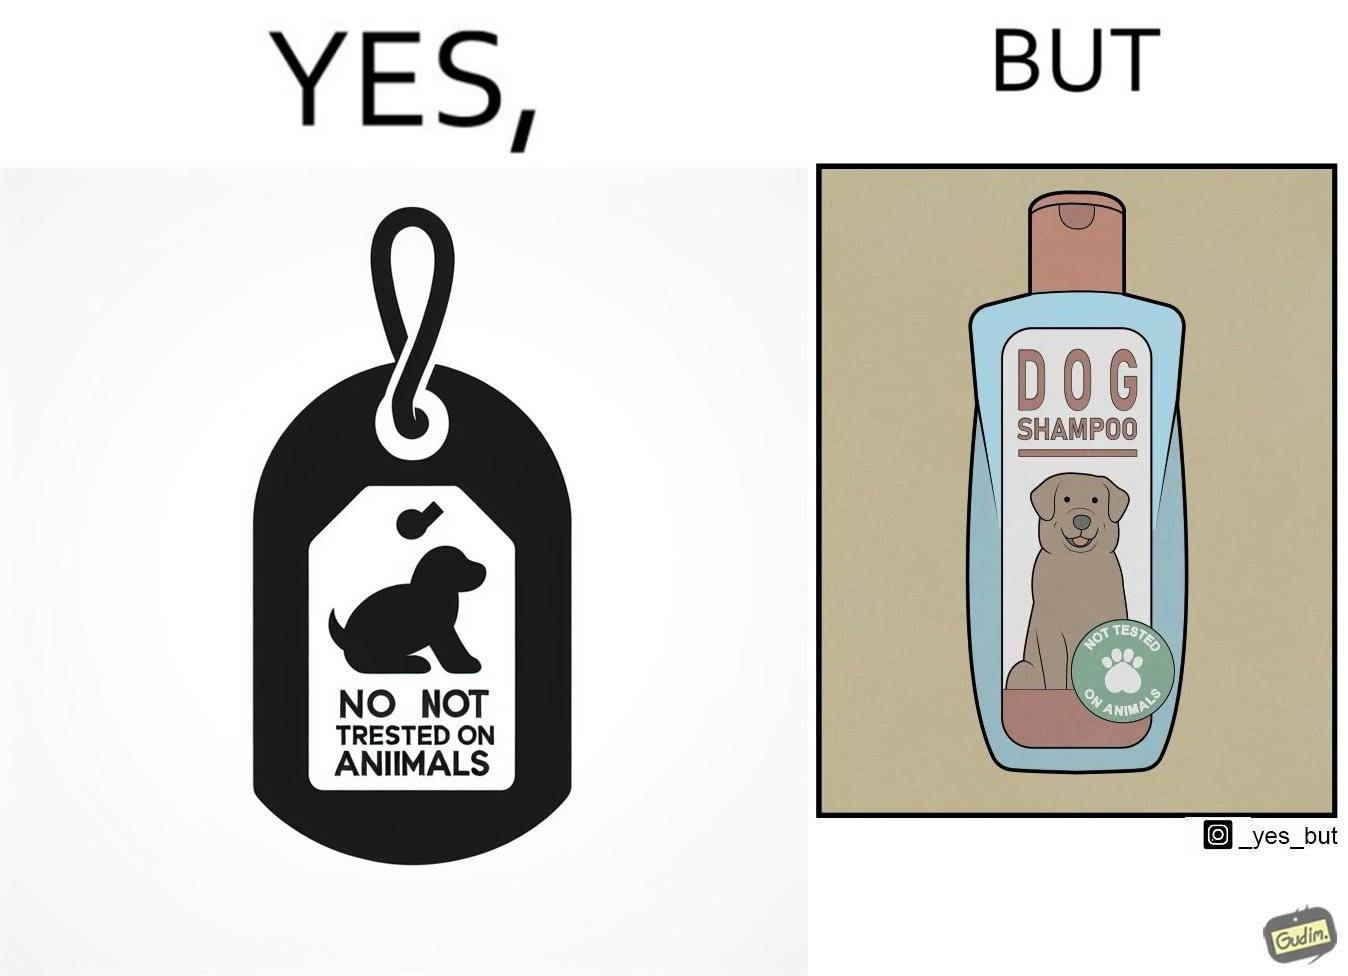Provide a description of this image. The images are ironic since a dog shampoo bottle has a sticker indicating that it has not been tested on animals and hence might not be safe for animal use. It is amusing that a product designed to be used by animals is not tested on animals for their safety 